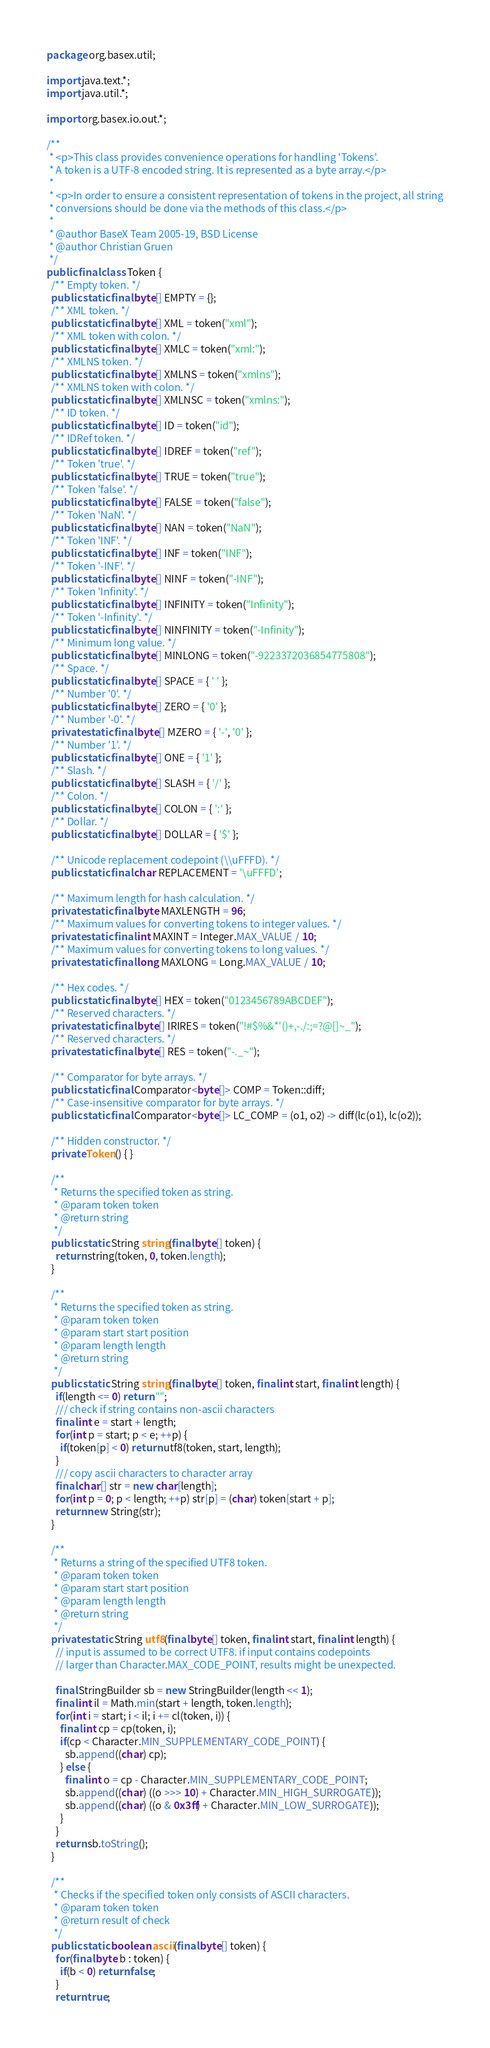Convert code to text. <code><loc_0><loc_0><loc_500><loc_500><_Java_>package org.basex.util;

import java.text.*;
import java.util.*;

import org.basex.io.out.*;

/**
 * <p>This class provides convenience operations for handling 'Tokens'.
 * A token is a UTF-8 encoded string. It is represented as a byte array.</p>
 *
 * <p>In order to ensure a consistent representation of tokens in the project, all string
 * conversions should be done via the methods of this class.</p>
 *
 * @author BaseX Team 2005-19, BSD License
 * @author Christian Gruen
 */
public final class Token {
  /** Empty token. */
  public static final byte[] EMPTY = {};
  /** XML token. */
  public static final byte[] XML = token("xml");
  /** XML token with colon. */
  public static final byte[] XMLC = token("xml:");
  /** XMLNS token. */
  public static final byte[] XMLNS = token("xmlns");
  /** XMLNS token with colon. */
  public static final byte[] XMLNSC = token("xmlns:");
  /** ID token. */
  public static final byte[] ID = token("id");
  /** IDRef token. */
  public static final byte[] IDREF = token("ref");
  /** Token 'true'. */
  public static final byte[] TRUE = token("true");
  /** Token 'false'. */
  public static final byte[] FALSE = token("false");
  /** Token 'NaN'. */
  public static final byte[] NAN = token("NaN");
  /** Token 'INF'. */
  public static final byte[] INF = token("INF");
  /** Token '-INF'. */
  public static final byte[] NINF = token("-INF");
  /** Token 'Infinity'. */
  public static final byte[] INFINITY = token("Infinity");
  /** Token '-Infinity'. */
  public static final byte[] NINFINITY = token("-Infinity");
  /** Minimum long value. */
  public static final byte[] MINLONG = token("-9223372036854775808");
  /** Space. */
  public static final byte[] SPACE = { ' ' };
  /** Number '0'. */
  public static final byte[] ZERO = { '0' };
  /** Number '-0'. */
  private static final byte[] MZERO = { '-', '0' };
  /** Number '1'. */
  public static final byte[] ONE = { '1' };
  /** Slash. */
  public static final byte[] SLASH = { '/' };
  /** Colon. */
  public static final byte[] COLON = { ':' };
  /** Dollar. */
  public static final byte[] DOLLAR = { '$' };

  /** Unicode replacement codepoint (\\uFFFD). */
  public static final char REPLACEMENT = '\uFFFD';

  /** Maximum length for hash calculation. */
  private static final byte MAXLENGTH = 96;
  /** Maximum values for converting tokens to integer values. */
  private static final int MAXINT = Integer.MAX_VALUE / 10;
  /** Maximum values for converting tokens to long values. */
  private static final long MAXLONG = Long.MAX_VALUE / 10;

  /** Hex codes. */
  public static final byte[] HEX = token("0123456789ABCDEF");
  /** Reserved characters. */
  private static final byte[] IRIRES = token("!#$%&*'()+,-./:;=?@[]~_");
  /** Reserved characters. */
  private static final byte[] RES = token("-._~");

  /** Comparator for byte arrays. */
  public static final Comparator<byte[]> COMP = Token::diff;
  /** Case-insensitive comparator for byte arrays. */
  public static final Comparator<byte[]> LC_COMP = (o1, o2) -> diff(lc(o1), lc(o2));

  /** Hidden constructor. */
  private Token() { }

  /**
   * Returns the specified token as string.
   * @param token token
   * @return string
   */
  public static String string(final byte[] token) {
    return string(token, 0, token.length);
  }

  /**
   * Returns the specified token as string.
   * @param token token
   * @param start start position
   * @param length length
   * @return string
   */
  public static String string(final byte[] token, final int start, final int length) {
    if(length <= 0) return "";
    /// check if string contains non-ascii characters
    final int e = start + length;
    for(int p = start; p < e; ++p) {
      if(token[p] < 0) return utf8(token, start, length);
    }
    /// copy ascii characters to character array
    final char[] str = new char[length];
    for(int p = 0; p < length; ++p) str[p] = (char) token[start + p];
    return new String(str);
  }

  /**
   * Returns a string of the specified UTF8 token.
   * @param token token
   * @param start start position
   * @param length length
   * @return string
   */
  private static String utf8(final byte[] token, final int start, final int length) {
    // input is assumed to be correct UTF8. if input contains codepoints
    // larger than Character.MAX_CODE_POINT, results might be unexpected.

    final StringBuilder sb = new StringBuilder(length << 1);
    final int il = Math.min(start + length, token.length);
    for(int i = start; i < il; i += cl(token, i)) {
      final int cp = cp(token, i);
      if(cp < Character.MIN_SUPPLEMENTARY_CODE_POINT) {
        sb.append((char) cp);
      } else {
        final int o = cp - Character.MIN_SUPPLEMENTARY_CODE_POINT;
        sb.append((char) ((o >>> 10) + Character.MIN_HIGH_SURROGATE));
        sb.append((char) ((o & 0x3ff) + Character.MIN_LOW_SURROGATE));
      }
    }
    return sb.toString();
  }

  /**
   * Checks if the specified token only consists of ASCII characters.
   * @param token token
   * @return result of check
   */
  public static boolean ascii(final byte[] token) {
    for(final byte b : token) {
      if(b < 0) return false;
    }
    return true;</code> 